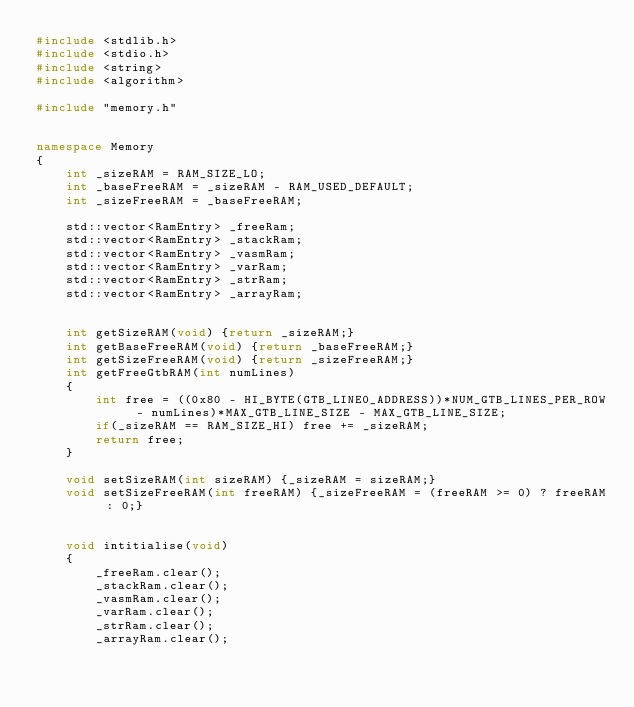<code> <loc_0><loc_0><loc_500><loc_500><_C++_>#include <stdlib.h>
#include <stdio.h>
#include <string>
#include <algorithm>

#include "memory.h"


namespace Memory
{
    int _sizeRAM = RAM_SIZE_LO;
    int _baseFreeRAM = _sizeRAM - RAM_USED_DEFAULT;
    int _sizeFreeRAM = _baseFreeRAM;

    std::vector<RamEntry> _freeRam;
    std::vector<RamEntry> _stackRam;
    std::vector<RamEntry> _vasmRam;
    std::vector<RamEntry> _varRam;
    std::vector<RamEntry> _strRam;
    std::vector<RamEntry> _arrayRam;


    int getSizeRAM(void) {return _sizeRAM;}
    int getBaseFreeRAM(void) {return _baseFreeRAM;}
    int getSizeFreeRAM(void) {return _sizeFreeRAM;}
    int getFreeGtbRAM(int numLines)
    {
        int free = ((0x80 - HI_BYTE(GTB_LINE0_ADDRESS))*NUM_GTB_LINES_PER_ROW - numLines)*MAX_GTB_LINE_SIZE - MAX_GTB_LINE_SIZE;
        if(_sizeRAM == RAM_SIZE_HI) free += _sizeRAM;
        return free;
    }

    void setSizeRAM(int sizeRAM) {_sizeRAM = sizeRAM;}
    void setSizeFreeRAM(int freeRAM) {_sizeFreeRAM = (freeRAM >= 0) ? freeRAM : 0;}


    void intitialise(void)
    {
        _freeRam.clear();
        _stackRam.clear();
        _vasmRam.clear();
        _varRam.clear();
        _strRam.clear();
        _arrayRam.clear();
</code> 